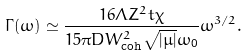<formula> <loc_0><loc_0><loc_500><loc_500>\Gamma ( \omega ) \simeq \frac { 1 6 \Lambda Z ^ { 2 } t \chi } { 1 5 \pi D W _ { \text {coh} } ^ { 2 } \sqrt { | \mu | } \omega _ { \text {0} } } \omega ^ { 3 / 2 } .</formula> 